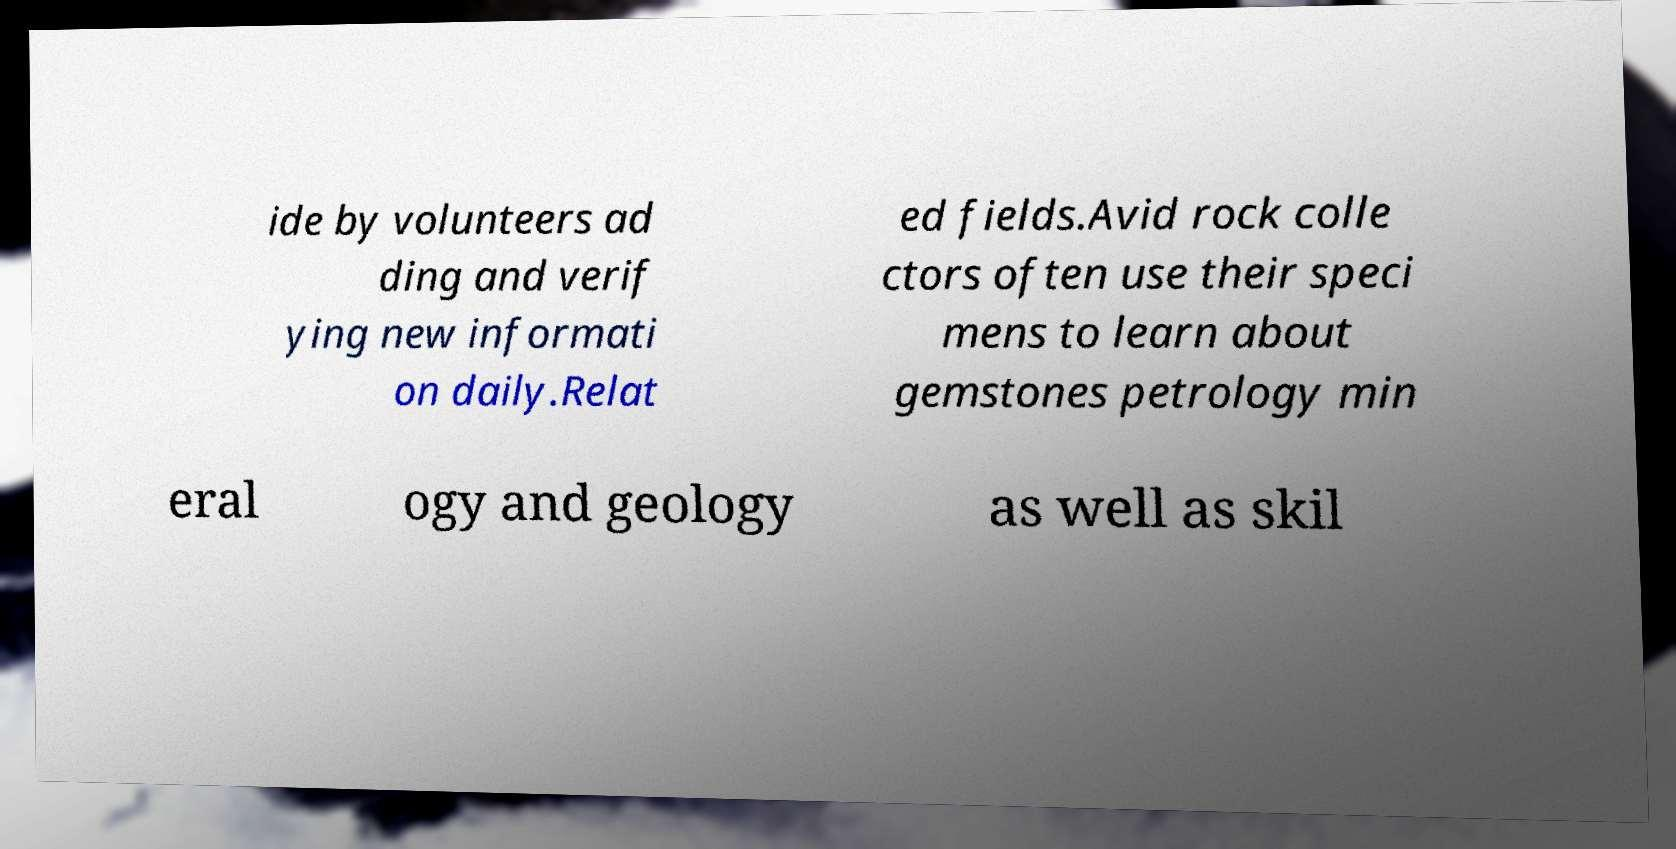For documentation purposes, I need the text within this image transcribed. Could you provide that? ide by volunteers ad ding and verif ying new informati on daily.Relat ed fields.Avid rock colle ctors often use their speci mens to learn about gemstones petrology min eral ogy and geology as well as skil 